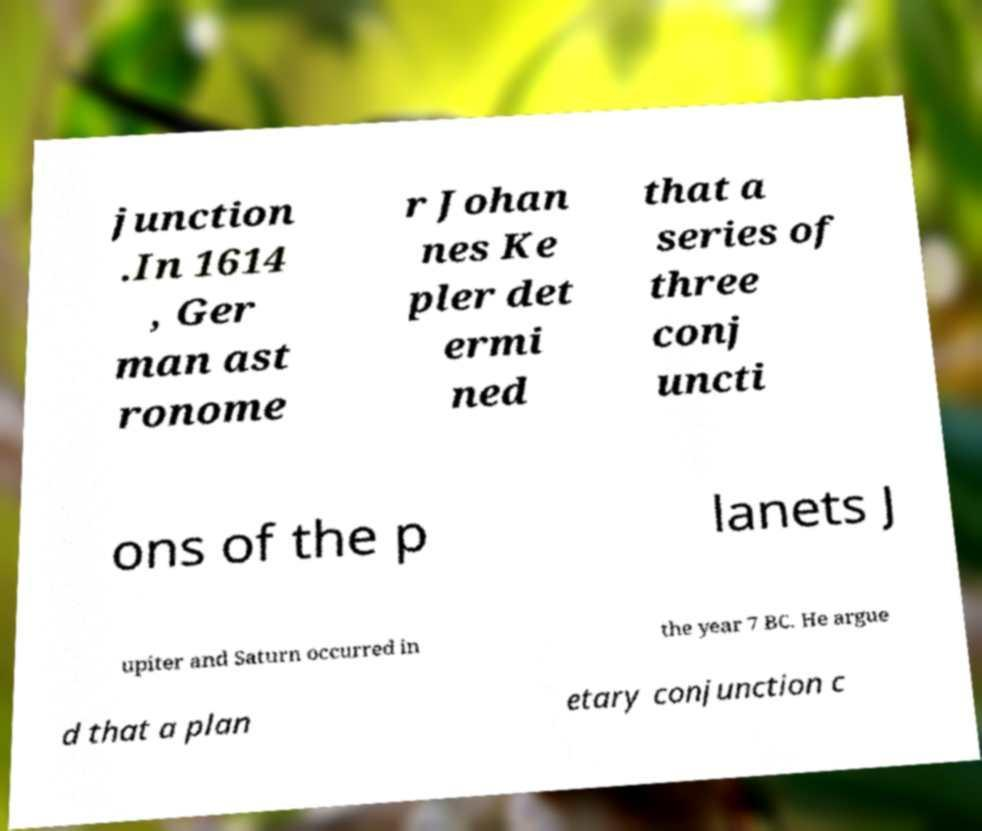What messages or text are displayed in this image? I need them in a readable, typed format. junction .In 1614 , Ger man ast ronome r Johan nes Ke pler det ermi ned that a series of three conj uncti ons of the p lanets J upiter and Saturn occurred in the year 7 BC. He argue d that a plan etary conjunction c 